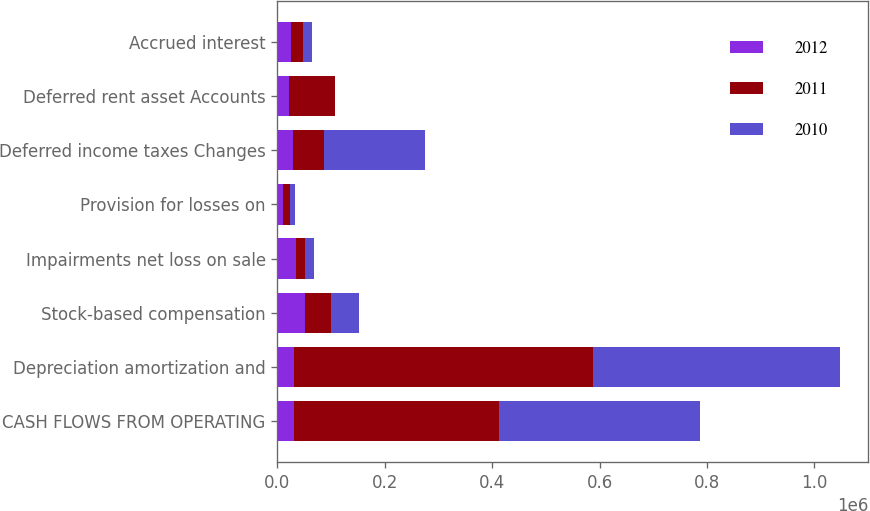Convert chart. <chart><loc_0><loc_0><loc_500><loc_500><stacked_bar_chart><ecel><fcel>CASH FLOWS FROM OPERATING<fcel>Depreciation amortization and<fcel>Stock-based compensation<fcel>Impairments net loss on sale<fcel>Provision for losses on<fcel>Deferred income taxes Changes<fcel>Deferred rent asset Accounts<fcel>Accrued interest<nl><fcel>2012<fcel>31790<fcel>31790<fcel>51983<fcel>34280<fcel>11090<fcel>29300<fcel>21880<fcel>25031<nl><fcel>2011<fcel>381840<fcel>555517<fcel>47437<fcel>17412<fcel>13092<fcel>56852<fcel>84699<fcel>23360<nl><fcel>2010<fcel>373606<fcel>460726<fcel>52555<fcel>16652<fcel>9408<fcel>188327<fcel>1603<fcel>16633<nl></chart> 